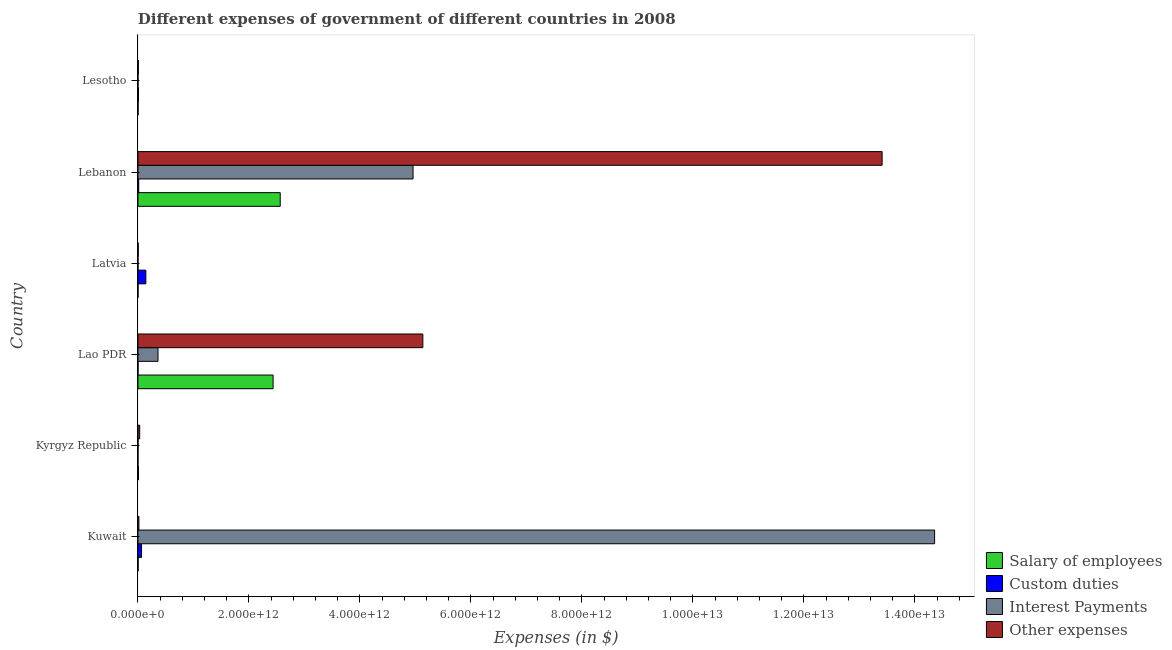Are the number of bars per tick equal to the number of legend labels?
Give a very brief answer. No. How many bars are there on the 5th tick from the bottom?
Offer a terse response. 4. What is the label of the 1st group of bars from the top?
Your answer should be very brief. Lesotho. What is the amount spent on interest payments in Kuwait?
Give a very brief answer. 1.44e+13. Across all countries, what is the maximum amount spent on interest payments?
Provide a short and direct response. 1.44e+13. Across all countries, what is the minimum amount spent on interest payments?
Your answer should be very brief. 5.90e+07. In which country was the amount spent on salary of employees maximum?
Make the answer very short. Lebanon. What is the total amount spent on other expenses in the graph?
Ensure brevity in your answer.  1.86e+13. What is the difference between the amount spent on other expenses in Kuwait and that in Lesotho?
Keep it short and to the point. 1.03e+1. What is the difference between the amount spent on custom duties in Lesotho and the amount spent on interest payments in Lao PDR?
Ensure brevity in your answer.  -3.53e+11. What is the average amount spent on other expenses per country?
Provide a succinct answer. 3.10e+12. What is the difference between the amount spent on custom duties and amount spent on interest payments in Lesotho?
Offer a terse response. 8.38e+09. In how many countries, is the amount spent on other expenses greater than 400000000000 $?
Offer a very short reply. 2. What is the ratio of the amount spent on other expenses in Kuwait to that in Lao PDR?
Your response must be concise. 0. What is the difference between the highest and the second highest amount spent on custom duties?
Give a very brief answer. 7.78e+1. What is the difference between the highest and the lowest amount spent on other expenses?
Your answer should be compact. 1.34e+13. What is the difference between two consecutive major ticks on the X-axis?
Ensure brevity in your answer.  2.00e+12. Are the values on the major ticks of X-axis written in scientific E-notation?
Keep it short and to the point. Yes. Where does the legend appear in the graph?
Keep it short and to the point. Bottom right. How many legend labels are there?
Offer a very short reply. 4. What is the title of the graph?
Offer a terse response. Different expenses of government of different countries in 2008. What is the label or title of the X-axis?
Provide a short and direct response. Expenses (in $). What is the label or title of the Y-axis?
Provide a short and direct response. Country. What is the Expenses (in $) in Salary of employees in Kuwait?
Offer a very short reply. 2.83e+09. What is the Expenses (in $) of Custom duties in Kuwait?
Offer a terse response. 6.43e+1. What is the Expenses (in $) in Interest Payments in Kuwait?
Offer a terse response. 1.44e+13. What is the Expenses (in $) of Other expenses in Kuwait?
Your answer should be very brief. 1.72e+1. What is the Expenses (in $) of Salary of employees in Kyrgyz Republic?
Your answer should be compact. 8.69e+09. What is the Expenses (in $) in Custom duties in Kyrgyz Republic?
Provide a succinct answer. 0. What is the Expenses (in $) in Interest Payments in Kyrgyz Republic?
Your answer should be very brief. 1.35e+09. What is the Expenses (in $) in Other expenses in Kyrgyz Republic?
Ensure brevity in your answer.  3.15e+1. What is the Expenses (in $) in Salary of employees in Lao PDR?
Keep it short and to the point. 2.44e+12. What is the Expenses (in $) of Custom duties in Lao PDR?
Your answer should be compact. 1.10e+09. What is the Expenses (in $) of Interest Payments in Lao PDR?
Offer a very short reply. 3.61e+11. What is the Expenses (in $) of Other expenses in Lao PDR?
Your answer should be very brief. 5.13e+12. What is the Expenses (in $) in Salary of employees in Latvia?
Make the answer very short. 8.98e+08. What is the Expenses (in $) of Custom duties in Latvia?
Keep it short and to the point. 1.42e+11. What is the Expenses (in $) of Interest Payments in Latvia?
Provide a short and direct response. 5.90e+07. What is the Expenses (in $) of Other expenses in Latvia?
Provide a succinct answer. 4.77e+09. What is the Expenses (in $) of Salary of employees in Lebanon?
Offer a terse response. 2.56e+12. What is the Expenses (in $) of Custom duties in Lebanon?
Keep it short and to the point. 1.37e+1. What is the Expenses (in $) in Interest Payments in Lebanon?
Your response must be concise. 4.96e+12. What is the Expenses (in $) of Other expenses in Lebanon?
Ensure brevity in your answer.  1.34e+13. What is the Expenses (in $) of Salary of employees in Lesotho?
Offer a terse response. 2.43e+09. What is the Expenses (in $) of Custom duties in Lesotho?
Your response must be concise. 8.50e+09. What is the Expenses (in $) in Interest Payments in Lesotho?
Give a very brief answer. 1.18e+08. What is the Expenses (in $) in Other expenses in Lesotho?
Provide a succinct answer. 6.87e+09. Across all countries, what is the maximum Expenses (in $) of Salary of employees?
Keep it short and to the point. 2.56e+12. Across all countries, what is the maximum Expenses (in $) in Custom duties?
Make the answer very short. 1.42e+11. Across all countries, what is the maximum Expenses (in $) in Interest Payments?
Give a very brief answer. 1.44e+13. Across all countries, what is the maximum Expenses (in $) in Other expenses?
Make the answer very short. 1.34e+13. Across all countries, what is the minimum Expenses (in $) in Salary of employees?
Offer a very short reply. 8.98e+08. Across all countries, what is the minimum Expenses (in $) in Custom duties?
Your answer should be compact. 0. Across all countries, what is the minimum Expenses (in $) of Interest Payments?
Give a very brief answer. 5.90e+07. Across all countries, what is the minimum Expenses (in $) of Other expenses?
Keep it short and to the point. 4.77e+09. What is the total Expenses (in $) of Salary of employees in the graph?
Give a very brief answer. 5.01e+12. What is the total Expenses (in $) in Custom duties in the graph?
Provide a short and direct response. 2.30e+11. What is the total Expenses (in $) of Interest Payments in the graph?
Your answer should be compact. 1.97e+13. What is the total Expenses (in $) in Other expenses in the graph?
Your answer should be compact. 1.86e+13. What is the difference between the Expenses (in $) of Salary of employees in Kuwait and that in Kyrgyz Republic?
Your answer should be very brief. -5.86e+09. What is the difference between the Expenses (in $) in Interest Payments in Kuwait and that in Kyrgyz Republic?
Give a very brief answer. 1.44e+13. What is the difference between the Expenses (in $) of Other expenses in Kuwait and that in Kyrgyz Republic?
Provide a short and direct response. -1.43e+1. What is the difference between the Expenses (in $) of Salary of employees in Kuwait and that in Lao PDR?
Keep it short and to the point. -2.43e+12. What is the difference between the Expenses (in $) of Custom duties in Kuwait and that in Lao PDR?
Keep it short and to the point. 6.32e+1. What is the difference between the Expenses (in $) of Interest Payments in Kuwait and that in Lao PDR?
Your answer should be compact. 1.40e+13. What is the difference between the Expenses (in $) in Other expenses in Kuwait and that in Lao PDR?
Make the answer very short. -5.12e+12. What is the difference between the Expenses (in $) of Salary of employees in Kuwait and that in Latvia?
Make the answer very short. 1.93e+09. What is the difference between the Expenses (in $) in Custom duties in Kuwait and that in Latvia?
Ensure brevity in your answer.  -7.78e+1. What is the difference between the Expenses (in $) in Interest Payments in Kuwait and that in Latvia?
Offer a terse response. 1.44e+13. What is the difference between the Expenses (in $) in Other expenses in Kuwait and that in Latvia?
Your response must be concise. 1.24e+1. What is the difference between the Expenses (in $) in Salary of employees in Kuwait and that in Lebanon?
Your response must be concise. -2.56e+12. What is the difference between the Expenses (in $) of Custom duties in Kuwait and that in Lebanon?
Keep it short and to the point. 5.06e+1. What is the difference between the Expenses (in $) of Interest Payments in Kuwait and that in Lebanon?
Provide a succinct answer. 9.40e+12. What is the difference between the Expenses (in $) in Other expenses in Kuwait and that in Lebanon?
Your answer should be very brief. -1.34e+13. What is the difference between the Expenses (in $) of Salary of employees in Kuwait and that in Lesotho?
Your answer should be compact. 4.02e+08. What is the difference between the Expenses (in $) of Custom duties in Kuwait and that in Lesotho?
Keep it short and to the point. 5.58e+1. What is the difference between the Expenses (in $) in Interest Payments in Kuwait and that in Lesotho?
Provide a short and direct response. 1.44e+13. What is the difference between the Expenses (in $) of Other expenses in Kuwait and that in Lesotho?
Provide a succinct answer. 1.03e+1. What is the difference between the Expenses (in $) in Salary of employees in Kyrgyz Republic and that in Lao PDR?
Keep it short and to the point. -2.43e+12. What is the difference between the Expenses (in $) in Interest Payments in Kyrgyz Republic and that in Lao PDR?
Keep it short and to the point. -3.60e+11. What is the difference between the Expenses (in $) of Other expenses in Kyrgyz Republic and that in Lao PDR?
Your answer should be very brief. -5.10e+12. What is the difference between the Expenses (in $) of Salary of employees in Kyrgyz Republic and that in Latvia?
Ensure brevity in your answer.  7.79e+09. What is the difference between the Expenses (in $) in Interest Payments in Kyrgyz Republic and that in Latvia?
Keep it short and to the point. 1.29e+09. What is the difference between the Expenses (in $) of Other expenses in Kyrgyz Republic and that in Latvia?
Give a very brief answer. 2.67e+1. What is the difference between the Expenses (in $) in Salary of employees in Kyrgyz Republic and that in Lebanon?
Ensure brevity in your answer.  -2.55e+12. What is the difference between the Expenses (in $) of Interest Payments in Kyrgyz Republic and that in Lebanon?
Your answer should be very brief. -4.96e+12. What is the difference between the Expenses (in $) of Other expenses in Kyrgyz Republic and that in Lebanon?
Keep it short and to the point. -1.34e+13. What is the difference between the Expenses (in $) of Salary of employees in Kyrgyz Republic and that in Lesotho?
Make the answer very short. 6.26e+09. What is the difference between the Expenses (in $) of Interest Payments in Kyrgyz Republic and that in Lesotho?
Offer a terse response. 1.23e+09. What is the difference between the Expenses (in $) of Other expenses in Kyrgyz Republic and that in Lesotho?
Provide a succinct answer. 2.46e+1. What is the difference between the Expenses (in $) of Salary of employees in Lao PDR and that in Latvia?
Provide a short and direct response. 2.43e+12. What is the difference between the Expenses (in $) of Custom duties in Lao PDR and that in Latvia?
Provide a succinct answer. -1.41e+11. What is the difference between the Expenses (in $) of Interest Payments in Lao PDR and that in Latvia?
Ensure brevity in your answer.  3.61e+11. What is the difference between the Expenses (in $) of Other expenses in Lao PDR and that in Latvia?
Offer a terse response. 5.13e+12. What is the difference between the Expenses (in $) of Salary of employees in Lao PDR and that in Lebanon?
Offer a very short reply. -1.28e+11. What is the difference between the Expenses (in $) of Custom duties in Lao PDR and that in Lebanon?
Provide a succinct answer. -1.26e+1. What is the difference between the Expenses (in $) of Interest Payments in Lao PDR and that in Lebanon?
Your answer should be very brief. -4.60e+12. What is the difference between the Expenses (in $) in Other expenses in Lao PDR and that in Lebanon?
Ensure brevity in your answer.  -8.28e+12. What is the difference between the Expenses (in $) of Salary of employees in Lao PDR and that in Lesotho?
Provide a short and direct response. 2.43e+12. What is the difference between the Expenses (in $) in Custom duties in Lao PDR and that in Lesotho?
Give a very brief answer. -7.40e+09. What is the difference between the Expenses (in $) in Interest Payments in Lao PDR and that in Lesotho?
Offer a terse response. 3.61e+11. What is the difference between the Expenses (in $) of Other expenses in Lao PDR and that in Lesotho?
Offer a very short reply. 5.13e+12. What is the difference between the Expenses (in $) of Salary of employees in Latvia and that in Lebanon?
Your answer should be very brief. -2.56e+12. What is the difference between the Expenses (in $) in Custom duties in Latvia and that in Lebanon?
Your answer should be compact. 1.28e+11. What is the difference between the Expenses (in $) in Interest Payments in Latvia and that in Lebanon?
Ensure brevity in your answer.  -4.96e+12. What is the difference between the Expenses (in $) of Other expenses in Latvia and that in Lebanon?
Ensure brevity in your answer.  -1.34e+13. What is the difference between the Expenses (in $) of Salary of employees in Latvia and that in Lesotho?
Your answer should be compact. -1.53e+09. What is the difference between the Expenses (in $) of Custom duties in Latvia and that in Lesotho?
Provide a succinct answer. 1.34e+11. What is the difference between the Expenses (in $) in Interest Payments in Latvia and that in Lesotho?
Offer a terse response. -5.94e+07. What is the difference between the Expenses (in $) in Other expenses in Latvia and that in Lesotho?
Provide a succinct answer. -2.10e+09. What is the difference between the Expenses (in $) in Salary of employees in Lebanon and that in Lesotho?
Make the answer very short. 2.56e+12. What is the difference between the Expenses (in $) in Custom duties in Lebanon and that in Lesotho?
Make the answer very short. 5.20e+09. What is the difference between the Expenses (in $) in Interest Payments in Lebanon and that in Lesotho?
Keep it short and to the point. 4.96e+12. What is the difference between the Expenses (in $) in Other expenses in Lebanon and that in Lesotho?
Your answer should be compact. 1.34e+13. What is the difference between the Expenses (in $) of Salary of employees in Kuwait and the Expenses (in $) of Interest Payments in Kyrgyz Republic?
Keep it short and to the point. 1.48e+09. What is the difference between the Expenses (in $) of Salary of employees in Kuwait and the Expenses (in $) of Other expenses in Kyrgyz Republic?
Your answer should be very brief. -2.87e+1. What is the difference between the Expenses (in $) of Custom duties in Kuwait and the Expenses (in $) of Interest Payments in Kyrgyz Republic?
Offer a very short reply. 6.30e+1. What is the difference between the Expenses (in $) of Custom duties in Kuwait and the Expenses (in $) of Other expenses in Kyrgyz Republic?
Offer a terse response. 3.28e+1. What is the difference between the Expenses (in $) of Interest Payments in Kuwait and the Expenses (in $) of Other expenses in Kyrgyz Republic?
Provide a short and direct response. 1.43e+13. What is the difference between the Expenses (in $) in Salary of employees in Kuwait and the Expenses (in $) in Custom duties in Lao PDR?
Give a very brief answer. 1.73e+09. What is the difference between the Expenses (in $) in Salary of employees in Kuwait and the Expenses (in $) in Interest Payments in Lao PDR?
Provide a succinct answer. -3.59e+11. What is the difference between the Expenses (in $) of Salary of employees in Kuwait and the Expenses (in $) of Other expenses in Lao PDR?
Give a very brief answer. -5.13e+12. What is the difference between the Expenses (in $) in Custom duties in Kuwait and the Expenses (in $) in Interest Payments in Lao PDR?
Your answer should be very brief. -2.97e+11. What is the difference between the Expenses (in $) of Custom duties in Kuwait and the Expenses (in $) of Other expenses in Lao PDR?
Keep it short and to the point. -5.07e+12. What is the difference between the Expenses (in $) of Interest Payments in Kuwait and the Expenses (in $) of Other expenses in Lao PDR?
Your answer should be compact. 9.22e+12. What is the difference between the Expenses (in $) in Salary of employees in Kuwait and the Expenses (in $) in Custom duties in Latvia?
Offer a very short reply. -1.39e+11. What is the difference between the Expenses (in $) in Salary of employees in Kuwait and the Expenses (in $) in Interest Payments in Latvia?
Offer a very short reply. 2.77e+09. What is the difference between the Expenses (in $) in Salary of employees in Kuwait and the Expenses (in $) in Other expenses in Latvia?
Your response must be concise. -1.94e+09. What is the difference between the Expenses (in $) of Custom duties in Kuwait and the Expenses (in $) of Interest Payments in Latvia?
Your answer should be compact. 6.42e+1. What is the difference between the Expenses (in $) in Custom duties in Kuwait and the Expenses (in $) in Other expenses in Latvia?
Make the answer very short. 5.95e+1. What is the difference between the Expenses (in $) of Interest Payments in Kuwait and the Expenses (in $) of Other expenses in Latvia?
Your response must be concise. 1.44e+13. What is the difference between the Expenses (in $) of Salary of employees in Kuwait and the Expenses (in $) of Custom duties in Lebanon?
Give a very brief answer. -1.09e+1. What is the difference between the Expenses (in $) of Salary of employees in Kuwait and the Expenses (in $) of Interest Payments in Lebanon?
Offer a terse response. -4.95e+12. What is the difference between the Expenses (in $) of Salary of employees in Kuwait and the Expenses (in $) of Other expenses in Lebanon?
Keep it short and to the point. -1.34e+13. What is the difference between the Expenses (in $) of Custom duties in Kuwait and the Expenses (in $) of Interest Payments in Lebanon?
Provide a short and direct response. -4.89e+12. What is the difference between the Expenses (in $) of Custom duties in Kuwait and the Expenses (in $) of Other expenses in Lebanon?
Offer a very short reply. -1.33e+13. What is the difference between the Expenses (in $) in Interest Payments in Kuwait and the Expenses (in $) in Other expenses in Lebanon?
Make the answer very short. 9.46e+11. What is the difference between the Expenses (in $) of Salary of employees in Kuwait and the Expenses (in $) of Custom duties in Lesotho?
Provide a succinct answer. -5.67e+09. What is the difference between the Expenses (in $) in Salary of employees in Kuwait and the Expenses (in $) in Interest Payments in Lesotho?
Make the answer very short. 2.71e+09. What is the difference between the Expenses (in $) of Salary of employees in Kuwait and the Expenses (in $) of Other expenses in Lesotho?
Offer a very short reply. -4.04e+09. What is the difference between the Expenses (in $) in Custom duties in Kuwait and the Expenses (in $) in Interest Payments in Lesotho?
Give a very brief answer. 6.42e+1. What is the difference between the Expenses (in $) of Custom duties in Kuwait and the Expenses (in $) of Other expenses in Lesotho?
Offer a very short reply. 5.74e+1. What is the difference between the Expenses (in $) of Interest Payments in Kuwait and the Expenses (in $) of Other expenses in Lesotho?
Offer a terse response. 1.43e+13. What is the difference between the Expenses (in $) in Salary of employees in Kyrgyz Republic and the Expenses (in $) in Custom duties in Lao PDR?
Offer a very short reply. 7.59e+09. What is the difference between the Expenses (in $) in Salary of employees in Kyrgyz Republic and the Expenses (in $) in Interest Payments in Lao PDR?
Your answer should be very brief. -3.53e+11. What is the difference between the Expenses (in $) of Salary of employees in Kyrgyz Republic and the Expenses (in $) of Other expenses in Lao PDR?
Provide a succinct answer. -5.12e+12. What is the difference between the Expenses (in $) in Interest Payments in Kyrgyz Republic and the Expenses (in $) in Other expenses in Lao PDR?
Ensure brevity in your answer.  -5.13e+12. What is the difference between the Expenses (in $) in Salary of employees in Kyrgyz Republic and the Expenses (in $) in Custom duties in Latvia?
Keep it short and to the point. -1.33e+11. What is the difference between the Expenses (in $) of Salary of employees in Kyrgyz Republic and the Expenses (in $) of Interest Payments in Latvia?
Make the answer very short. 8.63e+09. What is the difference between the Expenses (in $) of Salary of employees in Kyrgyz Republic and the Expenses (in $) of Other expenses in Latvia?
Your response must be concise. 3.92e+09. What is the difference between the Expenses (in $) of Interest Payments in Kyrgyz Republic and the Expenses (in $) of Other expenses in Latvia?
Your answer should be very brief. -3.42e+09. What is the difference between the Expenses (in $) in Salary of employees in Kyrgyz Republic and the Expenses (in $) in Custom duties in Lebanon?
Ensure brevity in your answer.  -5.02e+09. What is the difference between the Expenses (in $) of Salary of employees in Kyrgyz Republic and the Expenses (in $) of Interest Payments in Lebanon?
Your answer should be very brief. -4.95e+12. What is the difference between the Expenses (in $) of Salary of employees in Kyrgyz Republic and the Expenses (in $) of Other expenses in Lebanon?
Your answer should be very brief. -1.34e+13. What is the difference between the Expenses (in $) in Interest Payments in Kyrgyz Republic and the Expenses (in $) in Other expenses in Lebanon?
Your response must be concise. -1.34e+13. What is the difference between the Expenses (in $) in Salary of employees in Kyrgyz Republic and the Expenses (in $) in Custom duties in Lesotho?
Keep it short and to the point. 1.89e+08. What is the difference between the Expenses (in $) in Salary of employees in Kyrgyz Republic and the Expenses (in $) in Interest Payments in Lesotho?
Your answer should be very brief. 8.57e+09. What is the difference between the Expenses (in $) of Salary of employees in Kyrgyz Republic and the Expenses (in $) of Other expenses in Lesotho?
Make the answer very short. 1.82e+09. What is the difference between the Expenses (in $) in Interest Payments in Kyrgyz Republic and the Expenses (in $) in Other expenses in Lesotho?
Your answer should be very brief. -5.52e+09. What is the difference between the Expenses (in $) in Salary of employees in Lao PDR and the Expenses (in $) in Custom duties in Latvia?
Keep it short and to the point. 2.29e+12. What is the difference between the Expenses (in $) in Salary of employees in Lao PDR and the Expenses (in $) in Interest Payments in Latvia?
Make the answer very short. 2.44e+12. What is the difference between the Expenses (in $) in Salary of employees in Lao PDR and the Expenses (in $) in Other expenses in Latvia?
Provide a succinct answer. 2.43e+12. What is the difference between the Expenses (in $) of Custom duties in Lao PDR and the Expenses (in $) of Interest Payments in Latvia?
Offer a very short reply. 1.05e+09. What is the difference between the Expenses (in $) in Custom duties in Lao PDR and the Expenses (in $) in Other expenses in Latvia?
Provide a succinct answer. -3.66e+09. What is the difference between the Expenses (in $) of Interest Payments in Lao PDR and the Expenses (in $) of Other expenses in Latvia?
Offer a terse response. 3.57e+11. What is the difference between the Expenses (in $) in Salary of employees in Lao PDR and the Expenses (in $) in Custom duties in Lebanon?
Ensure brevity in your answer.  2.42e+12. What is the difference between the Expenses (in $) of Salary of employees in Lao PDR and the Expenses (in $) of Interest Payments in Lebanon?
Your answer should be very brief. -2.52e+12. What is the difference between the Expenses (in $) in Salary of employees in Lao PDR and the Expenses (in $) in Other expenses in Lebanon?
Your response must be concise. -1.10e+13. What is the difference between the Expenses (in $) of Custom duties in Lao PDR and the Expenses (in $) of Interest Payments in Lebanon?
Ensure brevity in your answer.  -4.96e+12. What is the difference between the Expenses (in $) of Custom duties in Lao PDR and the Expenses (in $) of Other expenses in Lebanon?
Your answer should be very brief. -1.34e+13. What is the difference between the Expenses (in $) of Interest Payments in Lao PDR and the Expenses (in $) of Other expenses in Lebanon?
Provide a succinct answer. -1.30e+13. What is the difference between the Expenses (in $) in Salary of employees in Lao PDR and the Expenses (in $) in Custom duties in Lesotho?
Give a very brief answer. 2.43e+12. What is the difference between the Expenses (in $) in Salary of employees in Lao PDR and the Expenses (in $) in Interest Payments in Lesotho?
Offer a terse response. 2.44e+12. What is the difference between the Expenses (in $) of Salary of employees in Lao PDR and the Expenses (in $) of Other expenses in Lesotho?
Offer a terse response. 2.43e+12. What is the difference between the Expenses (in $) in Custom duties in Lao PDR and the Expenses (in $) in Interest Payments in Lesotho?
Provide a succinct answer. 9.87e+08. What is the difference between the Expenses (in $) in Custom duties in Lao PDR and the Expenses (in $) in Other expenses in Lesotho?
Make the answer very short. -5.76e+09. What is the difference between the Expenses (in $) of Interest Payments in Lao PDR and the Expenses (in $) of Other expenses in Lesotho?
Your response must be concise. 3.55e+11. What is the difference between the Expenses (in $) in Salary of employees in Latvia and the Expenses (in $) in Custom duties in Lebanon?
Your answer should be compact. -1.28e+1. What is the difference between the Expenses (in $) in Salary of employees in Latvia and the Expenses (in $) in Interest Payments in Lebanon?
Offer a terse response. -4.96e+12. What is the difference between the Expenses (in $) in Salary of employees in Latvia and the Expenses (in $) in Other expenses in Lebanon?
Your answer should be compact. -1.34e+13. What is the difference between the Expenses (in $) of Custom duties in Latvia and the Expenses (in $) of Interest Payments in Lebanon?
Your response must be concise. -4.82e+12. What is the difference between the Expenses (in $) in Custom duties in Latvia and the Expenses (in $) in Other expenses in Lebanon?
Your response must be concise. -1.33e+13. What is the difference between the Expenses (in $) of Interest Payments in Latvia and the Expenses (in $) of Other expenses in Lebanon?
Your response must be concise. -1.34e+13. What is the difference between the Expenses (in $) of Salary of employees in Latvia and the Expenses (in $) of Custom duties in Lesotho?
Provide a succinct answer. -7.60e+09. What is the difference between the Expenses (in $) of Salary of employees in Latvia and the Expenses (in $) of Interest Payments in Lesotho?
Your answer should be very brief. 7.80e+08. What is the difference between the Expenses (in $) of Salary of employees in Latvia and the Expenses (in $) of Other expenses in Lesotho?
Provide a succinct answer. -5.97e+09. What is the difference between the Expenses (in $) in Custom duties in Latvia and the Expenses (in $) in Interest Payments in Lesotho?
Give a very brief answer. 1.42e+11. What is the difference between the Expenses (in $) in Custom duties in Latvia and the Expenses (in $) in Other expenses in Lesotho?
Ensure brevity in your answer.  1.35e+11. What is the difference between the Expenses (in $) in Interest Payments in Latvia and the Expenses (in $) in Other expenses in Lesotho?
Your response must be concise. -6.81e+09. What is the difference between the Expenses (in $) of Salary of employees in Lebanon and the Expenses (in $) of Custom duties in Lesotho?
Provide a succinct answer. 2.56e+12. What is the difference between the Expenses (in $) in Salary of employees in Lebanon and the Expenses (in $) in Interest Payments in Lesotho?
Your response must be concise. 2.56e+12. What is the difference between the Expenses (in $) in Salary of employees in Lebanon and the Expenses (in $) in Other expenses in Lesotho?
Provide a short and direct response. 2.56e+12. What is the difference between the Expenses (in $) of Custom duties in Lebanon and the Expenses (in $) of Interest Payments in Lesotho?
Ensure brevity in your answer.  1.36e+1. What is the difference between the Expenses (in $) in Custom duties in Lebanon and the Expenses (in $) in Other expenses in Lesotho?
Your answer should be very brief. 6.84e+09. What is the difference between the Expenses (in $) of Interest Payments in Lebanon and the Expenses (in $) of Other expenses in Lesotho?
Your answer should be compact. 4.95e+12. What is the average Expenses (in $) in Salary of employees per country?
Provide a succinct answer. 8.36e+11. What is the average Expenses (in $) of Custom duties per country?
Your answer should be compact. 3.83e+1. What is the average Expenses (in $) of Interest Payments per country?
Offer a terse response. 3.28e+12. What is the average Expenses (in $) of Other expenses per country?
Give a very brief answer. 3.10e+12. What is the difference between the Expenses (in $) in Salary of employees and Expenses (in $) in Custom duties in Kuwait?
Offer a very short reply. -6.15e+1. What is the difference between the Expenses (in $) in Salary of employees and Expenses (in $) in Interest Payments in Kuwait?
Make the answer very short. -1.44e+13. What is the difference between the Expenses (in $) in Salary of employees and Expenses (in $) in Other expenses in Kuwait?
Offer a terse response. -1.44e+1. What is the difference between the Expenses (in $) of Custom duties and Expenses (in $) of Interest Payments in Kuwait?
Your answer should be very brief. -1.43e+13. What is the difference between the Expenses (in $) of Custom duties and Expenses (in $) of Other expenses in Kuwait?
Keep it short and to the point. 4.71e+1. What is the difference between the Expenses (in $) in Interest Payments and Expenses (in $) in Other expenses in Kuwait?
Give a very brief answer. 1.43e+13. What is the difference between the Expenses (in $) of Salary of employees and Expenses (in $) of Interest Payments in Kyrgyz Republic?
Keep it short and to the point. 7.34e+09. What is the difference between the Expenses (in $) in Salary of employees and Expenses (in $) in Other expenses in Kyrgyz Republic?
Make the answer very short. -2.28e+1. What is the difference between the Expenses (in $) in Interest Payments and Expenses (in $) in Other expenses in Kyrgyz Republic?
Ensure brevity in your answer.  -3.02e+1. What is the difference between the Expenses (in $) of Salary of employees and Expenses (in $) of Custom duties in Lao PDR?
Provide a succinct answer. 2.43e+12. What is the difference between the Expenses (in $) in Salary of employees and Expenses (in $) in Interest Payments in Lao PDR?
Your answer should be very brief. 2.07e+12. What is the difference between the Expenses (in $) in Salary of employees and Expenses (in $) in Other expenses in Lao PDR?
Give a very brief answer. -2.70e+12. What is the difference between the Expenses (in $) in Custom duties and Expenses (in $) in Interest Payments in Lao PDR?
Provide a succinct answer. -3.60e+11. What is the difference between the Expenses (in $) in Custom duties and Expenses (in $) in Other expenses in Lao PDR?
Offer a very short reply. -5.13e+12. What is the difference between the Expenses (in $) of Interest Payments and Expenses (in $) of Other expenses in Lao PDR?
Make the answer very short. -4.77e+12. What is the difference between the Expenses (in $) in Salary of employees and Expenses (in $) in Custom duties in Latvia?
Keep it short and to the point. -1.41e+11. What is the difference between the Expenses (in $) in Salary of employees and Expenses (in $) in Interest Payments in Latvia?
Give a very brief answer. 8.39e+08. What is the difference between the Expenses (in $) of Salary of employees and Expenses (in $) of Other expenses in Latvia?
Provide a short and direct response. -3.87e+09. What is the difference between the Expenses (in $) in Custom duties and Expenses (in $) in Interest Payments in Latvia?
Keep it short and to the point. 1.42e+11. What is the difference between the Expenses (in $) in Custom duties and Expenses (in $) in Other expenses in Latvia?
Your answer should be very brief. 1.37e+11. What is the difference between the Expenses (in $) in Interest Payments and Expenses (in $) in Other expenses in Latvia?
Your response must be concise. -4.71e+09. What is the difference between the Expenses (in $) in Salary of employees and Expenses (in $) in Custom duties in Lebanon?
Provide a short and direct response. 2.55e+12. What is the difference between the Expenses (in $) in Salary of employees and Expenses (in $) in Interest Payments in Lebanon?
Your answer should be very brief. -2.39e+12. What is the difference between the Expenses (in $) in Salary of employees and Expenses (in $) in Other expenses in Lebanon?
Offer a very short reply. -1.08e+13. What is the difference between the Expenses (in $) in Custom duties and Expenses (in $) in Interest Payments in Lebanon?
Your answer should be very brief. -4.94e+12. What is the difference between the Expenses (in $) in Custom duties and Expenses (in $) in Other expenses in Lebanon?
Offer a terse response. -1.34e+13. What is the difference between the Expenses (in $) of Interest Payments and Expenses (in $) of Other expenses in Lebanon?
Ensure brevity in your answer.  -8.45e+12. What is the difference between the Expenses (in $) in Salary of employees and Expenses (in $) in Custom duties in Lesotho?
Offer a very short reply. -6.07e+09. What is the difference between the Expenses (in $) of Salary of employees and Expenses (in $) of Interest Payments in Lesotho?
Offer a very short reply. 2.31e+09. What is the difference between the Expenses (in $) in Salary of employees and Expenses (in $) in Other expenses in Lesotho?
Provide a succinct answer. -4.44e+09. What is the difference between the Expenses (in $) in Custom duties and Expenses (in $) in Interest Payments in Lesotho?
Your answer should be compact. 8.38e+09. What is the difference between the Expenses (in $) of Custom duties and Expenses (in $) of Other expenses in Lesotho?
Make the answer very short. 1.63e+09. What is the difference between the Expenses (in $) of Interest Payments and Expenses (in $) of Other expenses in Lesotho?
Provide a succinct answer. -6.75e+09. What is the ratio of the Expenses (in $) of Salary of employees in Kuwait to that in Kyrgyz Republic?
Give a very brief answer. 0.33. What is the ratio of the Expenses (in $) in Interest Payments in Kuwait to that in Kyrgyz Republic?
Your response must be concise. 1.06e+04. What is the ratio of the Expenses (in $) of Other expenses in Kuwait to that in Kyrgyz Republic?
Offer a very short reply. 0.55. What is the ratio of the Expenses (in $) of Salary of employees in Kuwait to that in Lao PDR?
Your response must be concise. 0. What is the ratio of the Expenses (in $) of Custom duties in Kuwait to that in Lao PDR?
Your response must be concise. 58.19. What is the ratio of the Expenses (in $) of Interest Payments in Kuwait to that in Lao PDR?
Give a very brief answer. 39.73. What is the ratio of the Expenses (in $) in Other expenses in Kuwait to that in Lao PDR?
Your response must be concise. 0. What is the ratio of the Expenses (in $) of Salary of employees in Kuwait to that in Latvia?
Offer a very short reply. 3.15. What is the ratio of the Expenses (in $) of Custom duties in Kuwait to that in Latvia?
Your answer should be very brief. 0.45. What is the ratio of the Expenses (in $) of Interest Payments in Kuwait to that in Latvia?
Ensure brevity in your answer.  2.43e+05. What is the ratio of the Expenses (in $) in Other expenses in Kuwait to that in Latvia?
Provide a short and direct response. 3.61. What is the ratio of the Expenses (in $) in Salary of employees in Kuwait to that in Lebanon?
Provide a short and direct response. 0. What is the ratio of the Expenses (in $) in Custom duties in Kuwait to that in Lebanon?
Offer a very short reply. 4.69. What is the ratio of the Expenses (in $) in Interest Payments in Kuwait to that in Lebanon?
Offer a terse response. 2.9. What is the ratio of the Expenses (in $) in Other expenses in Kuwait to that in Lebanon?
Make the answer very short. 0. What is the ratio of the Expenses (in $) of Salary of employees in Kuwait to that in Lesotho?
Make the answer very short. 1.17. What is the ratio of the Expenses (in $) of Custom duties in Kuwait to that in Lesotho?
Your answer should be compact. 7.56. What is the ratio of the Expenses (in $) in Interest Payments in Kuwait to that in Lesotho?
Provide a short and direct response. 1.21e+05. What is the ratio of the Expenses (in $) of Other expenses in Kuwait to that in Lesotho?
Your response must be concise. 2.51. What is the ratio of the Expenses (in $) of Salary of employees in Kyrgyz Republic to that in Lao PDR?
Your answer should be very brief. 0. What is the ratio of the Expenses (in $) in Interest Payments in Kyrgyz Republic to that in Lao PDR?
Give a very brief answer. 0. What is the ratio of the Expenses (in $) of Other expenses in Kyrgyz Republic to that in Lao PDR?
Offer a terse response. 0.01. What is the ratio of the Expenses (in $) of Salary of employees in Kyrgyz Republic to that in Latvia?
Provide a succinct answer. 9.68. What is the ratio of the Expenses (in $) of Interest Payments in Kyrgyz Republic to that in Latvia?
Give a very brief answer. 22.85. What is the ratio of the Expenses (in $) in Other expenses in Kyrgyz Republic to that in Latvia?
Give a very brief answer. 6.61. What is the ratio of the Expenses (in $) of Salary of employees in Kyrgyz Republic to that in Lebanon?
Your response must be concise. 0. What is the ratio of the Expenses (in $) in Interest Payments in Kyrgyz Republic to that in Lebanon?
Make the answer very short. 0. What is the ratio of the Expenses (in $) of Other expenses in Kyrgyz Republic to that in Lebanon?
Keep it short and to the point. 0. What is the ratio of the Expenses (in $) of Salary of employees in Kyrgyz Republic to that in Lesotho?
Provide a succinct answer. 3.58. What is the ratio of the Expenses (in $) of Interest Payments in Kyrgyz Republic to that in Lesotho?
Give a very brief answer. 11.39. What is the ratio of the Expenses (in $) of Other expenses in Kyrgyz Republic to that in Lesotho?
Keep it short and to the point. 4.59. What is the ratio of the Expenses (in $) in Salary of employees in Lao PDR to that in Latvia?
Make the answer very short. 2712.1. What is the ratio of the Expenses (in $) in Custom duties in Lao PDR to that in Latvia?
Your answer should be compact. 0.01. What is the ratio of the Expenses (in $) in Interest Payments in Lao PDR to that in Latvia?
Your response must be concise. 6124.99. What is the ratio of the Expenses (in $) of Other expenses in Lao PDR to that in Latvia?
Your answer should be very brief. 1076.47. What is the ratio of the Expenses (in $) of Salary of employees in Lao PDR to that in Lebanon?
Your answer should be very brief. 0.95. What is the ratio of the Expenses (in $) of Custom duties in Lao PDR to that in Lebanon?
Keep it short and to the point. 0.08. What is the ratio of the Expenses (in $) of Interest Payments in Lao PDR to that in Lebanon?
Ensure brevity in your answer.  0.07. What is the ratio of the Expenses (in $) of Other expenses in Lao PDR to that in Lebanon?
Offer a terse response. 0.38. What is the ratio of the Expenses (in $) in Salary of employees in Lao PDR to that in Lesotho?
Your response must be concise. 1002.87. What is the ratio of the Expenses (in $) in Custom duties in Lao PDR to that in Lesotho?
Provide a short and direct response. 0.13. What is the ratio of the Expenses (in $) in Interest Payments in Lao PDR to that in Lesotho?
Provide a succinct answer. 3052.15. What is the ratio of the Expenses (in $) in Other expenses in Lao PDR to that in Lesotho?
Ensure brevity in your answer.  747.46. What is the ratio of the Expenses (in $) in Custom duties in Latvia to that in Lebanon?
Make the answer very short. 10.36. What is the ratio of the Expenses (in $) of Interest Payments in Latvia to that in Lebanon?
Your response must be concise. 0. What is the ratio of the Expenses (in $) of Salary of employees in Latvia to that in Lesotho?
Give a very brief answer. 0.37. What is the ratio of the Expenses (in $) of Custom duties in Latvia to that in Lesotho?
Keep it short and to the point. 16.71. What is the ratio of the Expenses (in $) of Interest Payments in Latvia to that in Lesotho?
Give a very brief answer. 0.5. What is the ratio of the Expenses (in $) of Other expenses in Latvia to that in Lesotho?
Provide a short and direct response. 0.69. What is the ratio of the Expenses (in $) of Salary of employees in Lebanon to that in Lesotho?
Your response must be concise. 1055.61. What is the ratio of the Expenses (in $) in Custom duties in Lebanon to that in Lesotho?
Provide a succinct answer. 1.61. What is the ratio of the Expenses (in $) in Interest Payments in Lebanon to that in Lesotho?
Provide a short and direct response. 4.19e+04. What is the ratio of the Expenses (in $) of Other expenses in Lebanon to that in Lesotho?
Provide a succinct answer. 1952.5. What is the difference between the highest and the second highest Expenses (in $) of Salary of employees?
Offer a very short reply. 1.28e+11. What is the difference between the highest and the second highest Expenses (in $) in Custom duties?
Offer a terse response. 7.78e+1. What is the difference between the highest and the second highest Expenses (in $) in Interest Payments?
Your answer should be compact. 9.40e+12. What is the difference between the highest and the second highest Expenses (in $) in Other expenses?
Provide a short and direct response. 8.28e+12. What is the difference between the highest and the lowest Expenses (in $) in Salary of employees?
Your answer should be very brief. 2.56e+12. What is the difference between the highest and the lowest Expenses (in $) of Custom duties?
Offer a terse response. 1.42e+11. What is the difference between the highest and the lowest Expenses (in $) in Interest Payments?
Your answer should be very brief. 1.44e+13. What is the difference between the highest and the lowest Expenses (in $) in Other expenses?
Offer a terse response. 1.34e+13. 